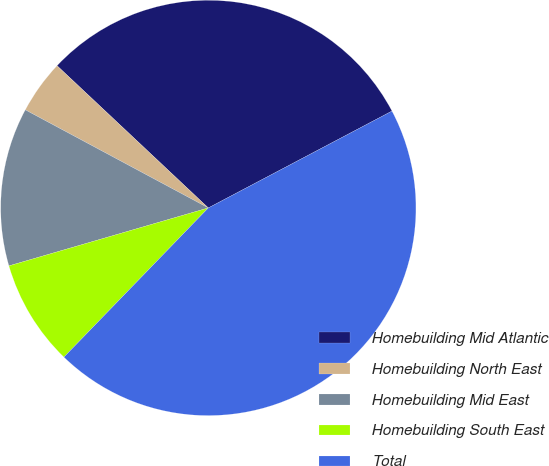Convert chart to OTSL. <chart><loc_0><loc_0><loc_500><loc_500><pie_chart><fcel>Homebuilding Mid Atlantic<fcel>Homebuilding North East<fcel>Homebuilding Mid East<fcel>Homebuilding South East<fcel>Total<nl><fcel>30.27%<fcel>4.18%<fcel>12.33%<fcel>8.26%<fcel>44.96%<nl></chart> 